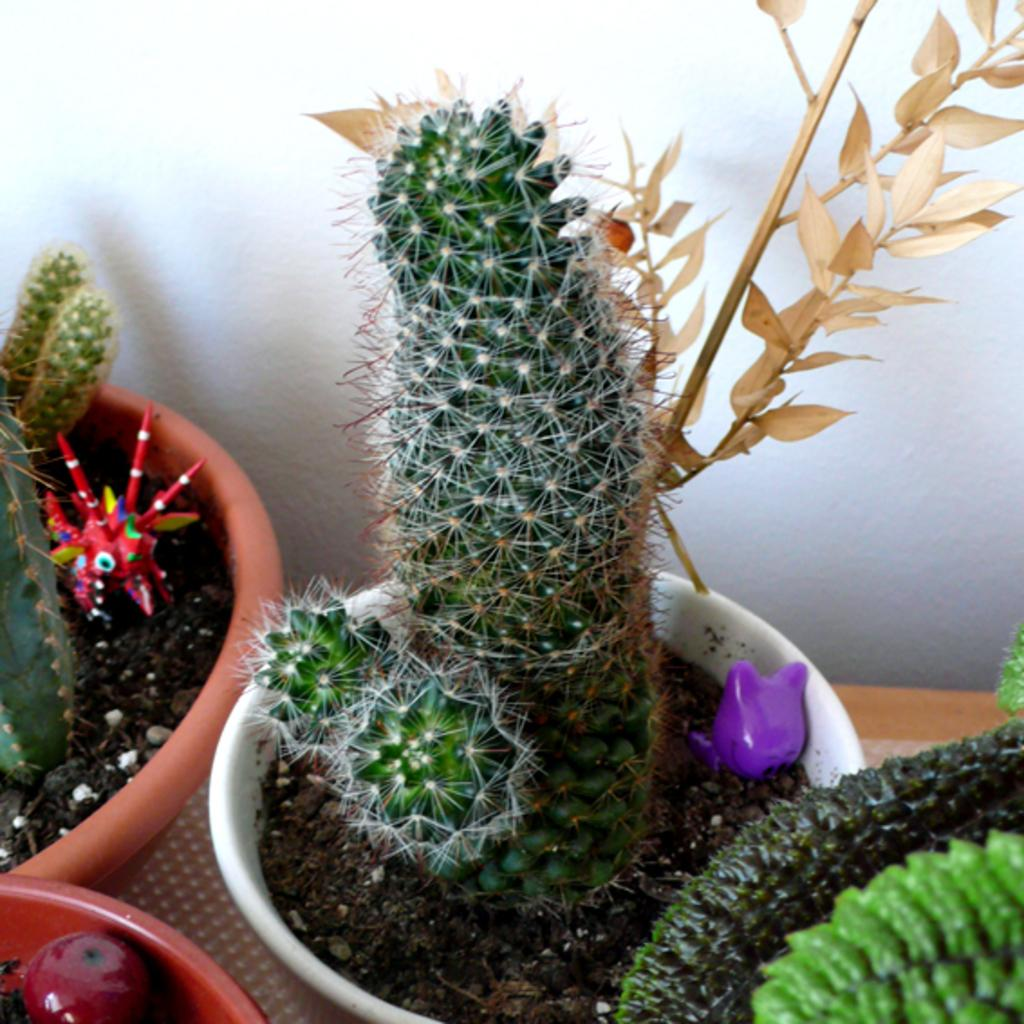What is placed in the pots in the image? There are plants and toys in the pots in the image. Can you describe the background of the image? There is a white-colored wall in the background of the image. What type of yam is being used as a self-portrait in the image? There is no yam or self-portrait present in the image. 